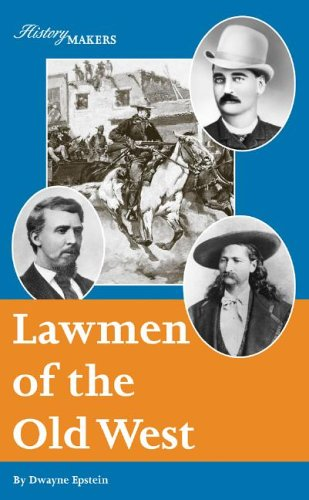Can you name a few lawmen featured in this book? The book features several notable figures, including Wyatt Earp and Wild Bill Hickok, who were instrumental in shaping the legal landscape of the American West through their daring and sometimes controversial actions. 